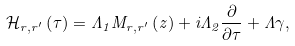<formula> <loc_0><loc_0><loc_500><loc_500>\mathcal { H } _ { r , r ^ { \prime } } \left ( \tau \right ) = \Lambda _ { 1 } M _ { r , r ^ { \prime } } \left ( z \right ) + i \Lambda _ { 2 } \frac { \partial } { \partial \tau } + \Lambda \gamma ,</formula> 